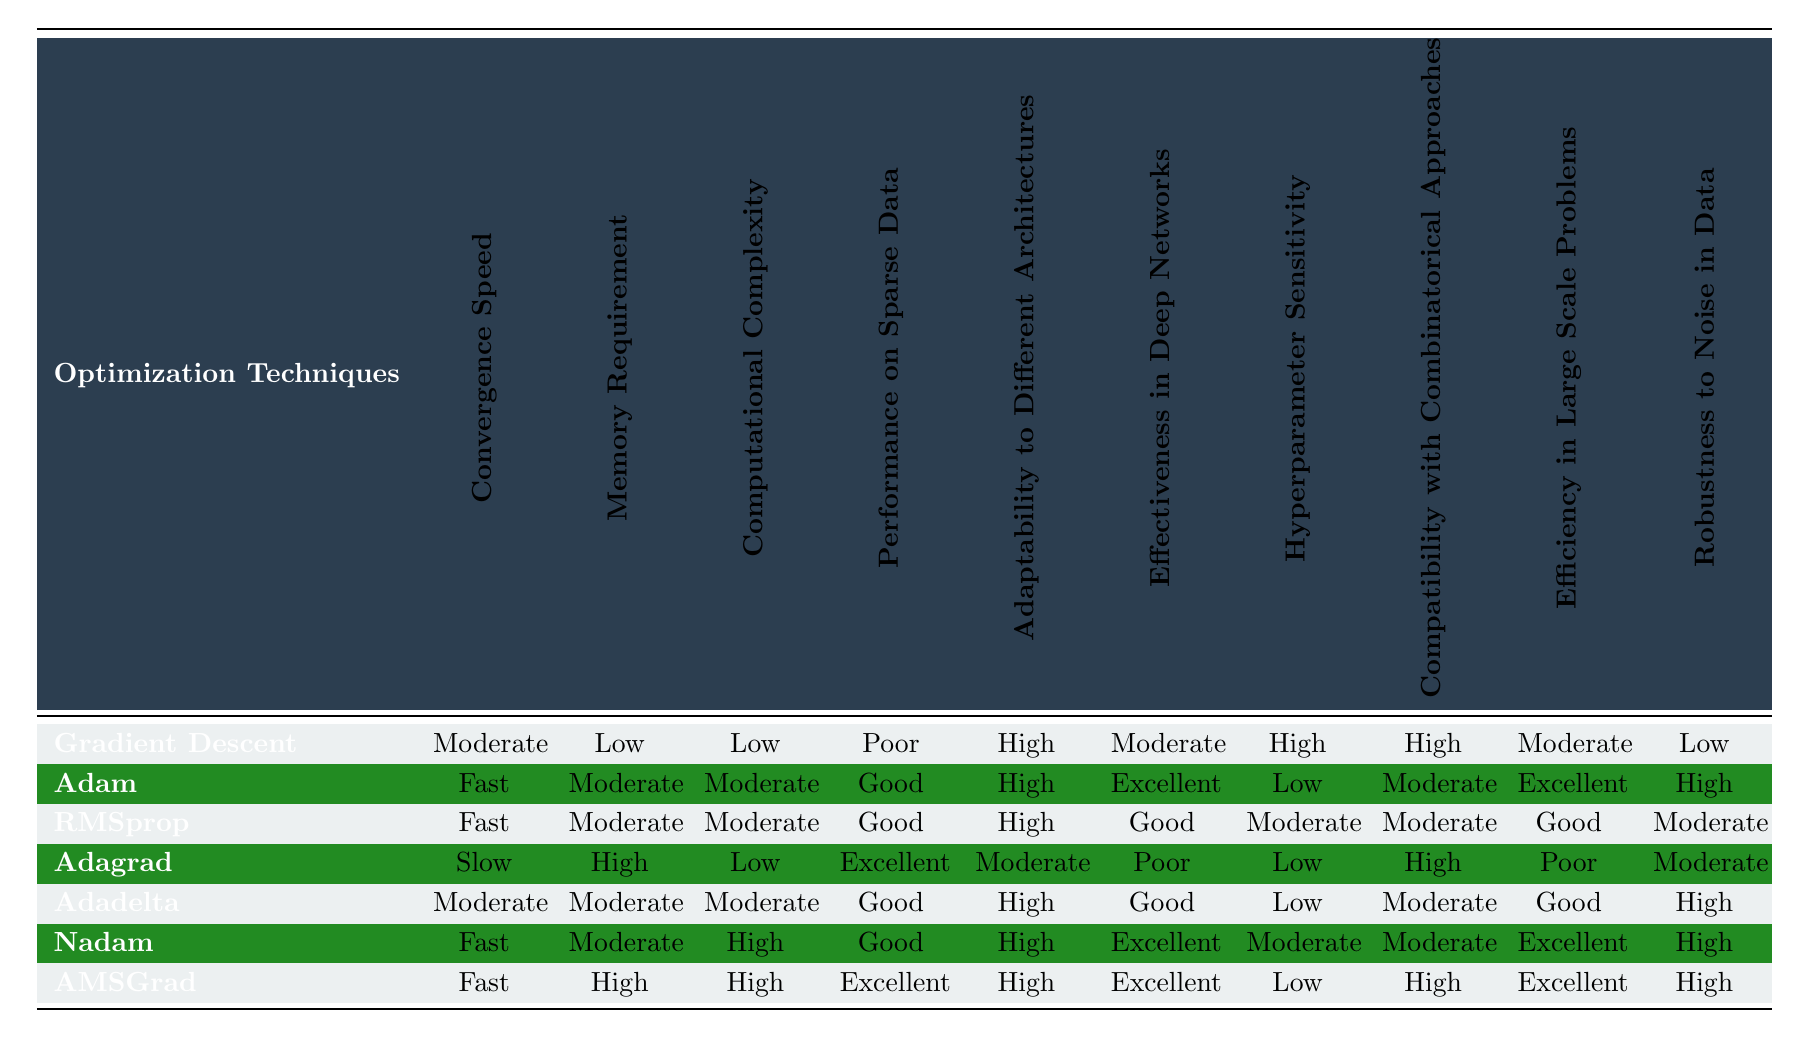What is the convergence speed of Adam? From the table, the convergence speed of Adam is listed as "Fast."
Answer: Fast Which optimization technique has the lowest memory requirement? By checking the "Memory Requirement" column, Gradient Descent is marked with "Low," indicating it has the lowest memory requirement.
Answer: Gradient Descent Are AMSGrad and Adagrad effective in deep networks? Looking at the "Effectiveness in Deep Networks" column, AMSGrad has "Excellent," while Adagrad has "Poor." Thus, AMSGrad is effective but Adagrad is not.
Answer: No How many optimization techniques have "High" robustness to noise in data? In the "Robustness to Noise in Data" column, we can identify those with "High" classification: Adam, Nadam, and AMSGrad. This totals three techniques.
Answer: 3 What is the average convergence speed level for the techniques with "Fast" performance on sparse data? The techniques with "Fast" performance on sparse data are Adam, RMSprop, Nadam, and AMSGrad. Their convergence speeds are Fast, Fast, Fast, and Fast, respectively. The average is thus "Fast."
Answer: Fast Which optimization technique requires high memory but is excellent in performance on sparse data? From the "Memory Requirement" and "Performance on Sparse Data" columns, we see that AMSGrad requires "High" memory and performs "Excellent" on sparse data.
Answer: AMSGrad Is there any optimization technique that has both moderate hyperparameter sensitivity and good performance in large-scale problems? Checking the relevant columns, we notice that RMSprop shows "Moderate" hyperparameter sensitivity and "Good" efficiency in large-scale problems.
Answer: Yes Which optimization techniques exhibit good adaptability to different architectures and are also effective in deep networks? Reviewing the table, Adam, Nadam, and AMSGrad all have "High" adaptability and effectiveness rated as "Excellent" for Adam and Nadam, and "Excellent" for AMSGrad. Thus, Adam, Nadam, and AMSGrad fit this criterion.
Answer: 3 What can be inferred about the compatibility of techniques with combinatorial approaches in relation to computational complexity? Evaluating the "Compatibility with Combinatorical Approaches" and "Computational Complexity" columns, techniques with High compatibility (Gradient Descent, Adagrad, AMSGrad) have Low to High computational complexity. This indicates varying relationships showing that high compatibility isn't limited to low computational complexity.
Answer: Varies Identify the optimization technique most robust to noise that also has a moderate requirement for memory. In "Robustness to Noise in Data," Adadelta, and Nadam have "High" robustness, and both require "Moderate" memory, hence both are candidates.
Answer: Adadelta and Nadam 